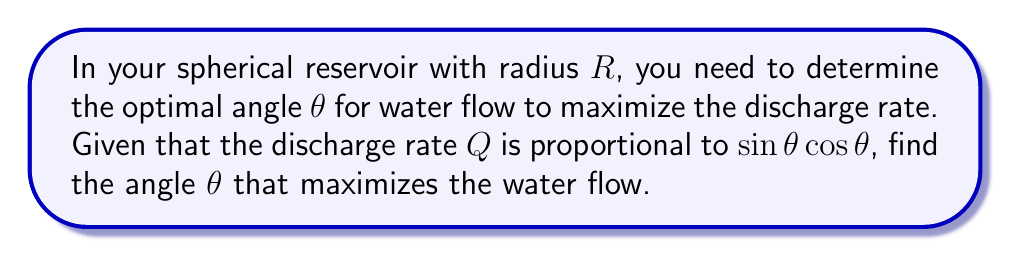Show me your answer to this math problem. To find the optimal angle for water flow in a spherical reservoir, we need to maximize the discharge rate $Q$. Let's approach this step-by-step:

1) The discharge rate $Q$ is proportional to $\sin\theta\cos\theta$. We can express this as:

   $$Q = k\sin\theta\cos\theta$$

   where $k$ is a constant of proportionality.

2) To maximize $Q$, we need to maximize $\sin\theta\cos\theta$. This expression can be rewritten using the trigonometric identity for the sine of a double angle:

   $$\sin\theta\cos\theta = \frac{1}{2}\sin(2\theta)$$

3) Now our problem reduces to maximizing $\sin(2\theta)$.

4) We know that the sine function reaches its maximum value of 1 when its argument is 90° or $\frac{\pi}{2}$ radians.

5) Therefore, we want:

   $$2\theta = \frac{\pi}{2}$$

6) Solving for $\theta$:

   $$\theta = \frac{\pi}{4} = 45°$$

7) To verify this is a maximum and not a minimum, we could take the second derivative and confirm it's negative at this point, but given the nature of the sine function, we know this is indeed the maximum.

Thus, the optimal angle for water flow in the spherical reservoir is 45°.

[asy]
import geometry;

size(200);
draw(Circle((0,0),1));
draw((0,0)--(1/sqrt(2),1/sqrt(2)));
draw((1/sqrt(2),1/sqrt(2))--(1/sqrt(2),0), dashed);
draw(arc((0,0),0.3,0,45));
label("$R$", (0.5,0), S);
label("$\theta$", (0.15,0.1), NE);
label("45°", (0.4,0.4), NE);
</asy>
Answer: $45°$ or $\frac{\pi}{4}$ radians 